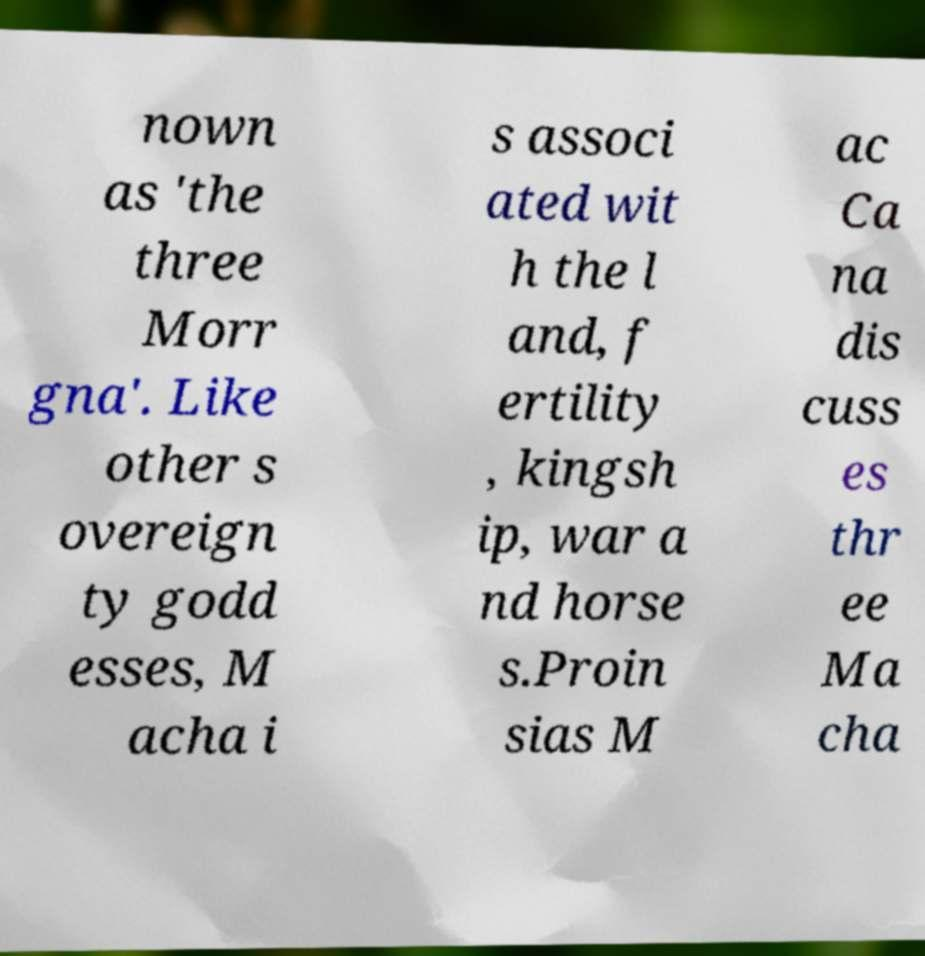Please identify and transcribe the text found in this image. nown as 'the three Morr gna'. Like other s overeign ty godd esses, M acha i s associ ated wit h the l and, f ertility , kingsh ip, war a nd horse s.Proin sias M ac Ca na dis cuss es thr ee Ma cha 